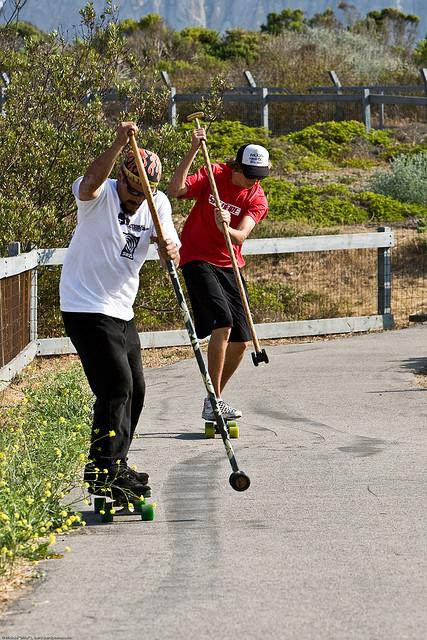What are the men riding on? Please explain your reasoning. skateboard. The men are riding skateboards down the road. 